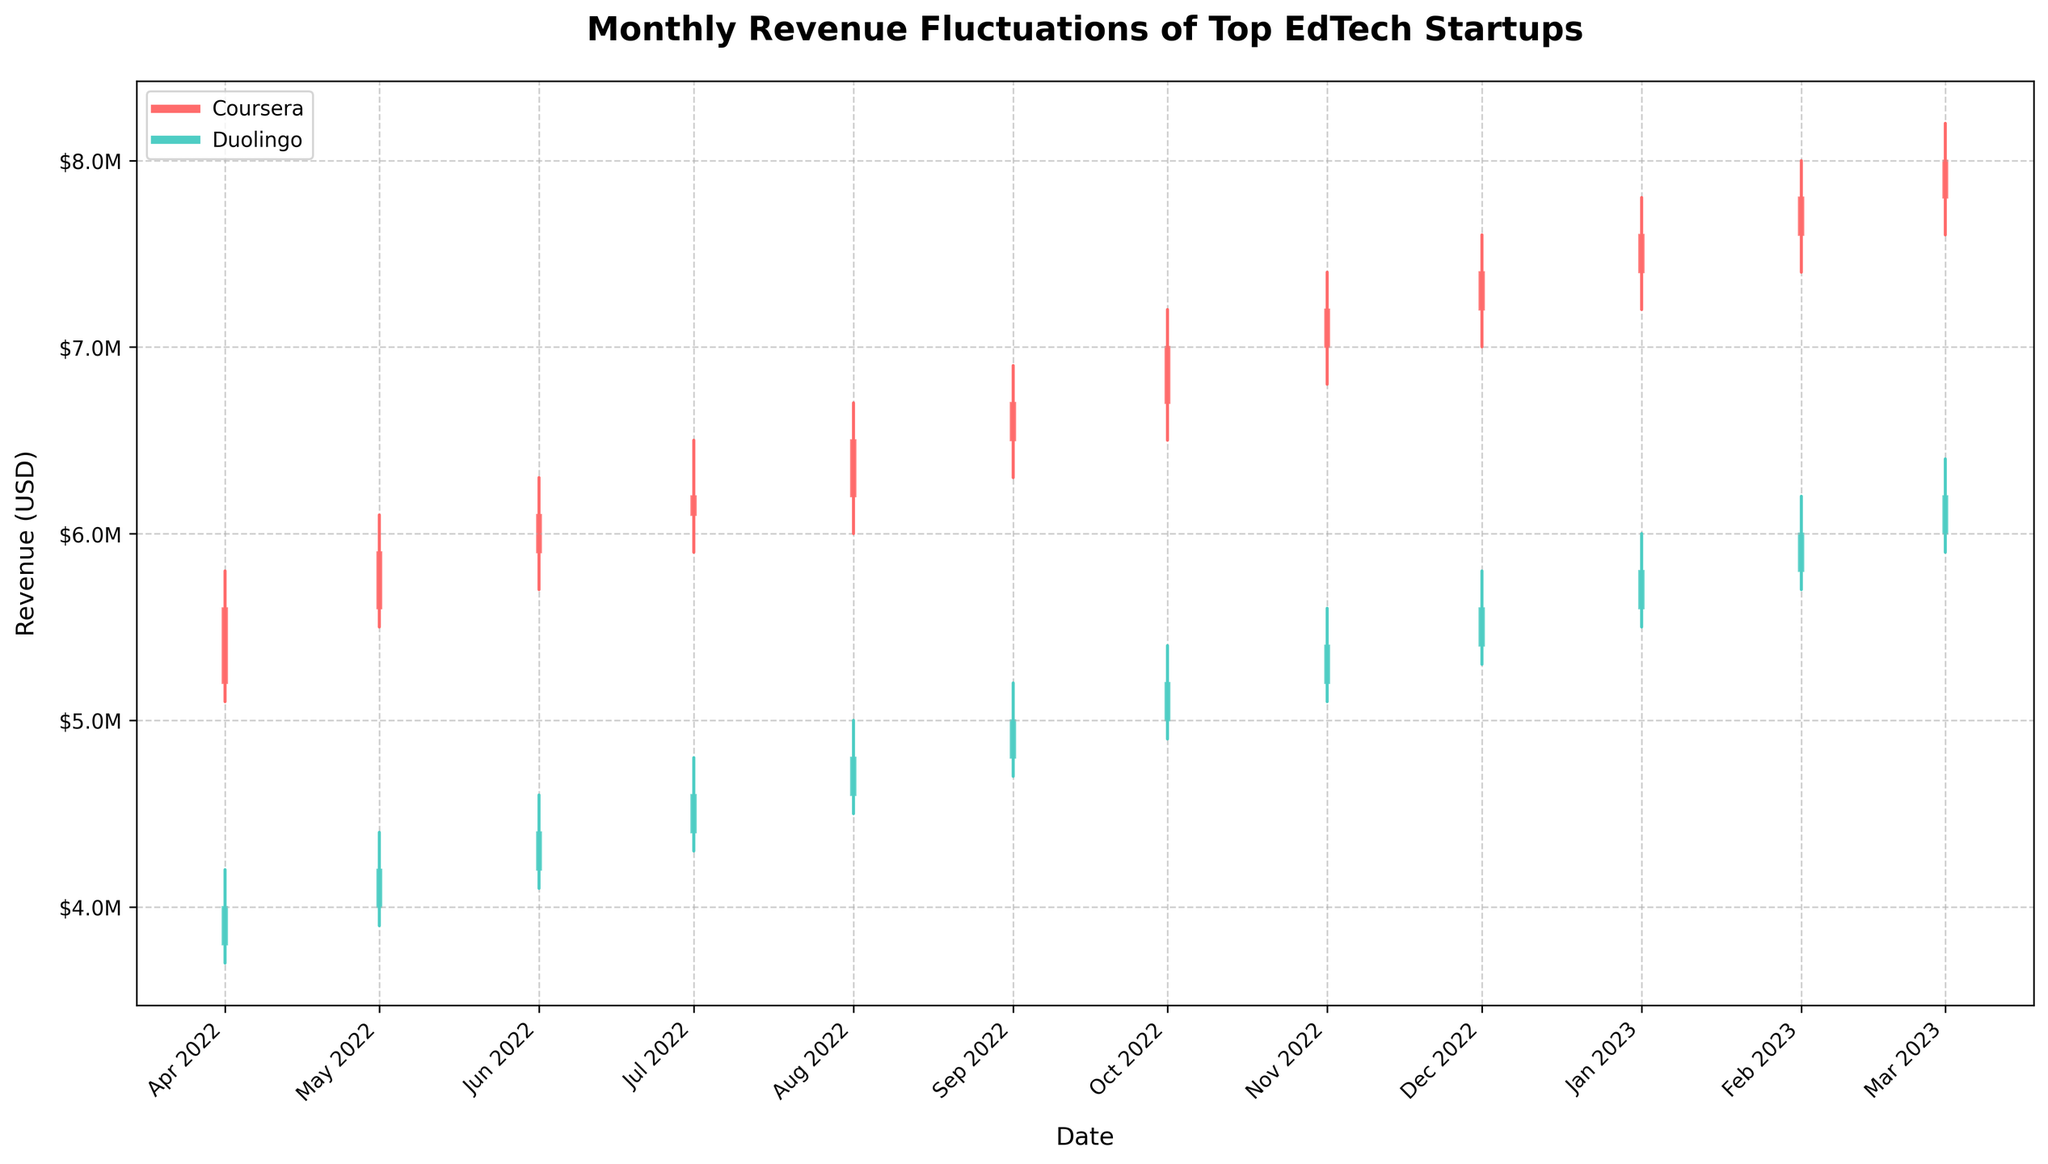What is the title of the figure? The title is usually placed at the top of the figure and is often in a larger or bolder font to distinguish it as the title. Here, it reads: "Monthly Revenue Fluctuations of Top EdTech Startups."
Answer: Monthly Revenue Fluctuations of Top EdTech Startups Which company had the highest closing revenue in March 2023? To find this, look for the bar representing March 2023 on the x-axis for each company, and compare the height of the closing revenue figures. Coursera's closing revenue is $8,000,000, and Duolingo's is $6,200,000.
Answer: Coursera What is the color used to represent Coursera? Colors can be identified by looking at the legend on the figure. Coursera is represented by the color red.
Answer: Red Which company experienced the largest increase in revenue from April 2022 to March 2023? To determine this, note the closing revenue for each company in April 2022 and March 2023 and calculate the difference. Coursera's revenue increased from $5,600,000 to $8,000,000, and Duolingo's from $4,000,000 to $6,200,000. Coursera had the larger increase of $2,400,000 compared to Duolingo's $2,200,000.
Answer: Coursera In which month did Duolingo have the highest revenue volatility? Revenue volatility can be inferred from the difference between the high and low values in a given month. For Duolingo, the highest volatility is in September 2022 where the high was $5,200,000 and the low was $4,700,000, a difference of $500,000.
Answer: September 2022 What was Coursera's revenue in November 2022? Look for the November 2022 data point for Coursera and read the closing value from the bar representing that month. It is $7,200,000.
Answer: $7,200,000 How did Duolingo's revenue change from January 2023 to February 2023? Check the closing figures for Duolingo in January 2023 ($5,800,000) and February 2023 ($6,000,000). The revenue increased by $200,000.
Answer: Increased by $200,000 Did Coursera or Duolingo close at a higher revenue in August 2022? Compare the closing values for both companies in August 2022. Coursera closed at $6,500,000, whereas Duolingo closed at $4,800,000.
Answer: Coursera Which company showed a consistent increase in revenue for six consecutive months? Look at the trend in the closing values for each company. Coursera shows a consistent increase in revenue from April 2022 to September 2022.
Answer: Coursera In which month did Coursera see the largest single-month revenue increase? Identify the month-over-month revenue increases for Coursera by comparing closing values. The largest increase occurred from October 2022 ($7,000,000) to November 2022 ($7,200,000), an increase of $200,000.
Answer: October to November 2022 